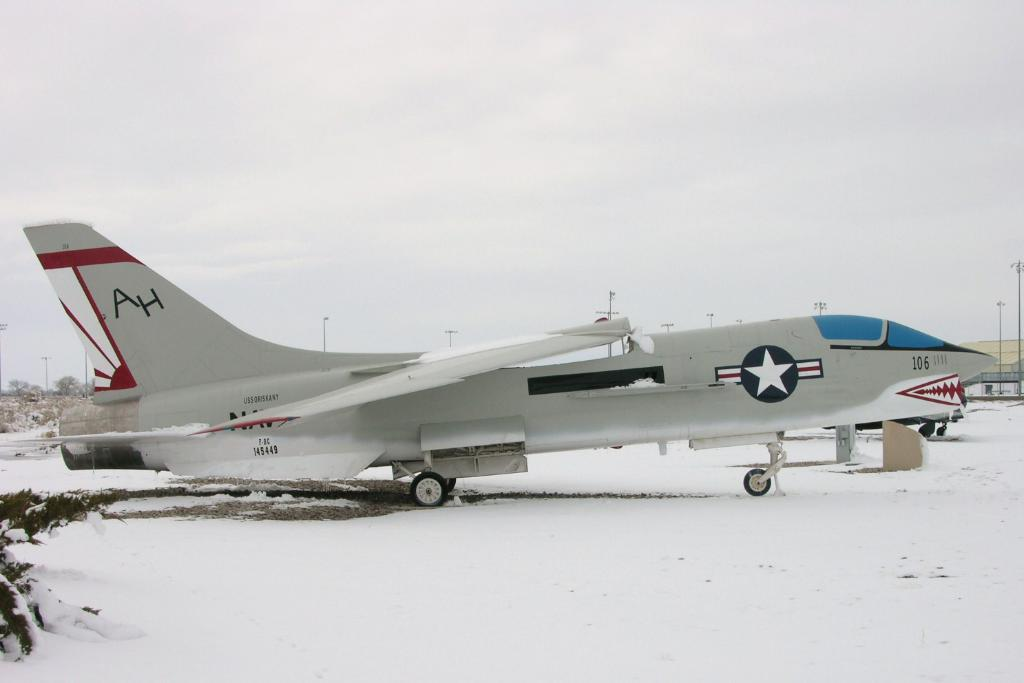<image>
Write a terse but informative summary of the picture. The initials AH are seen on the tail section of a gray, red and black military aircraft. 